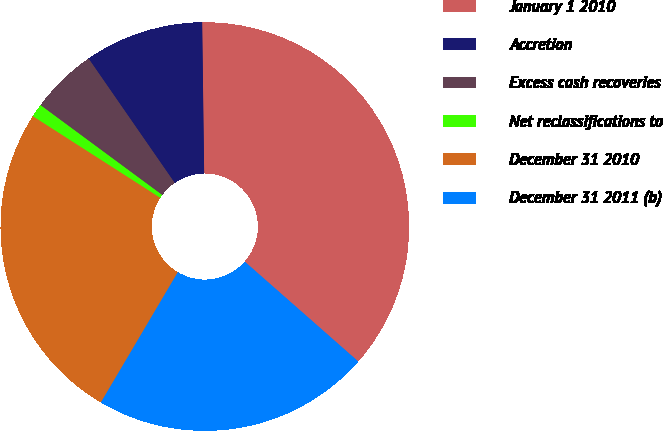Convert chart. <chart><loc_0><loc_0><loc_500><loc_500><pie_chart><fcel>January 1 2010<fcel>Accretion<fcel>Excess cash recoveries<fcel>Net reclassifications to<fcel>December 31 2010<fcel>December 31 2011 (b)<nl><fcel>36.69%<fcel>9.43%<fcel>5.24%<fcel>1.05%<fcel>25.58%<fcel>22.01%<nl></chart> 